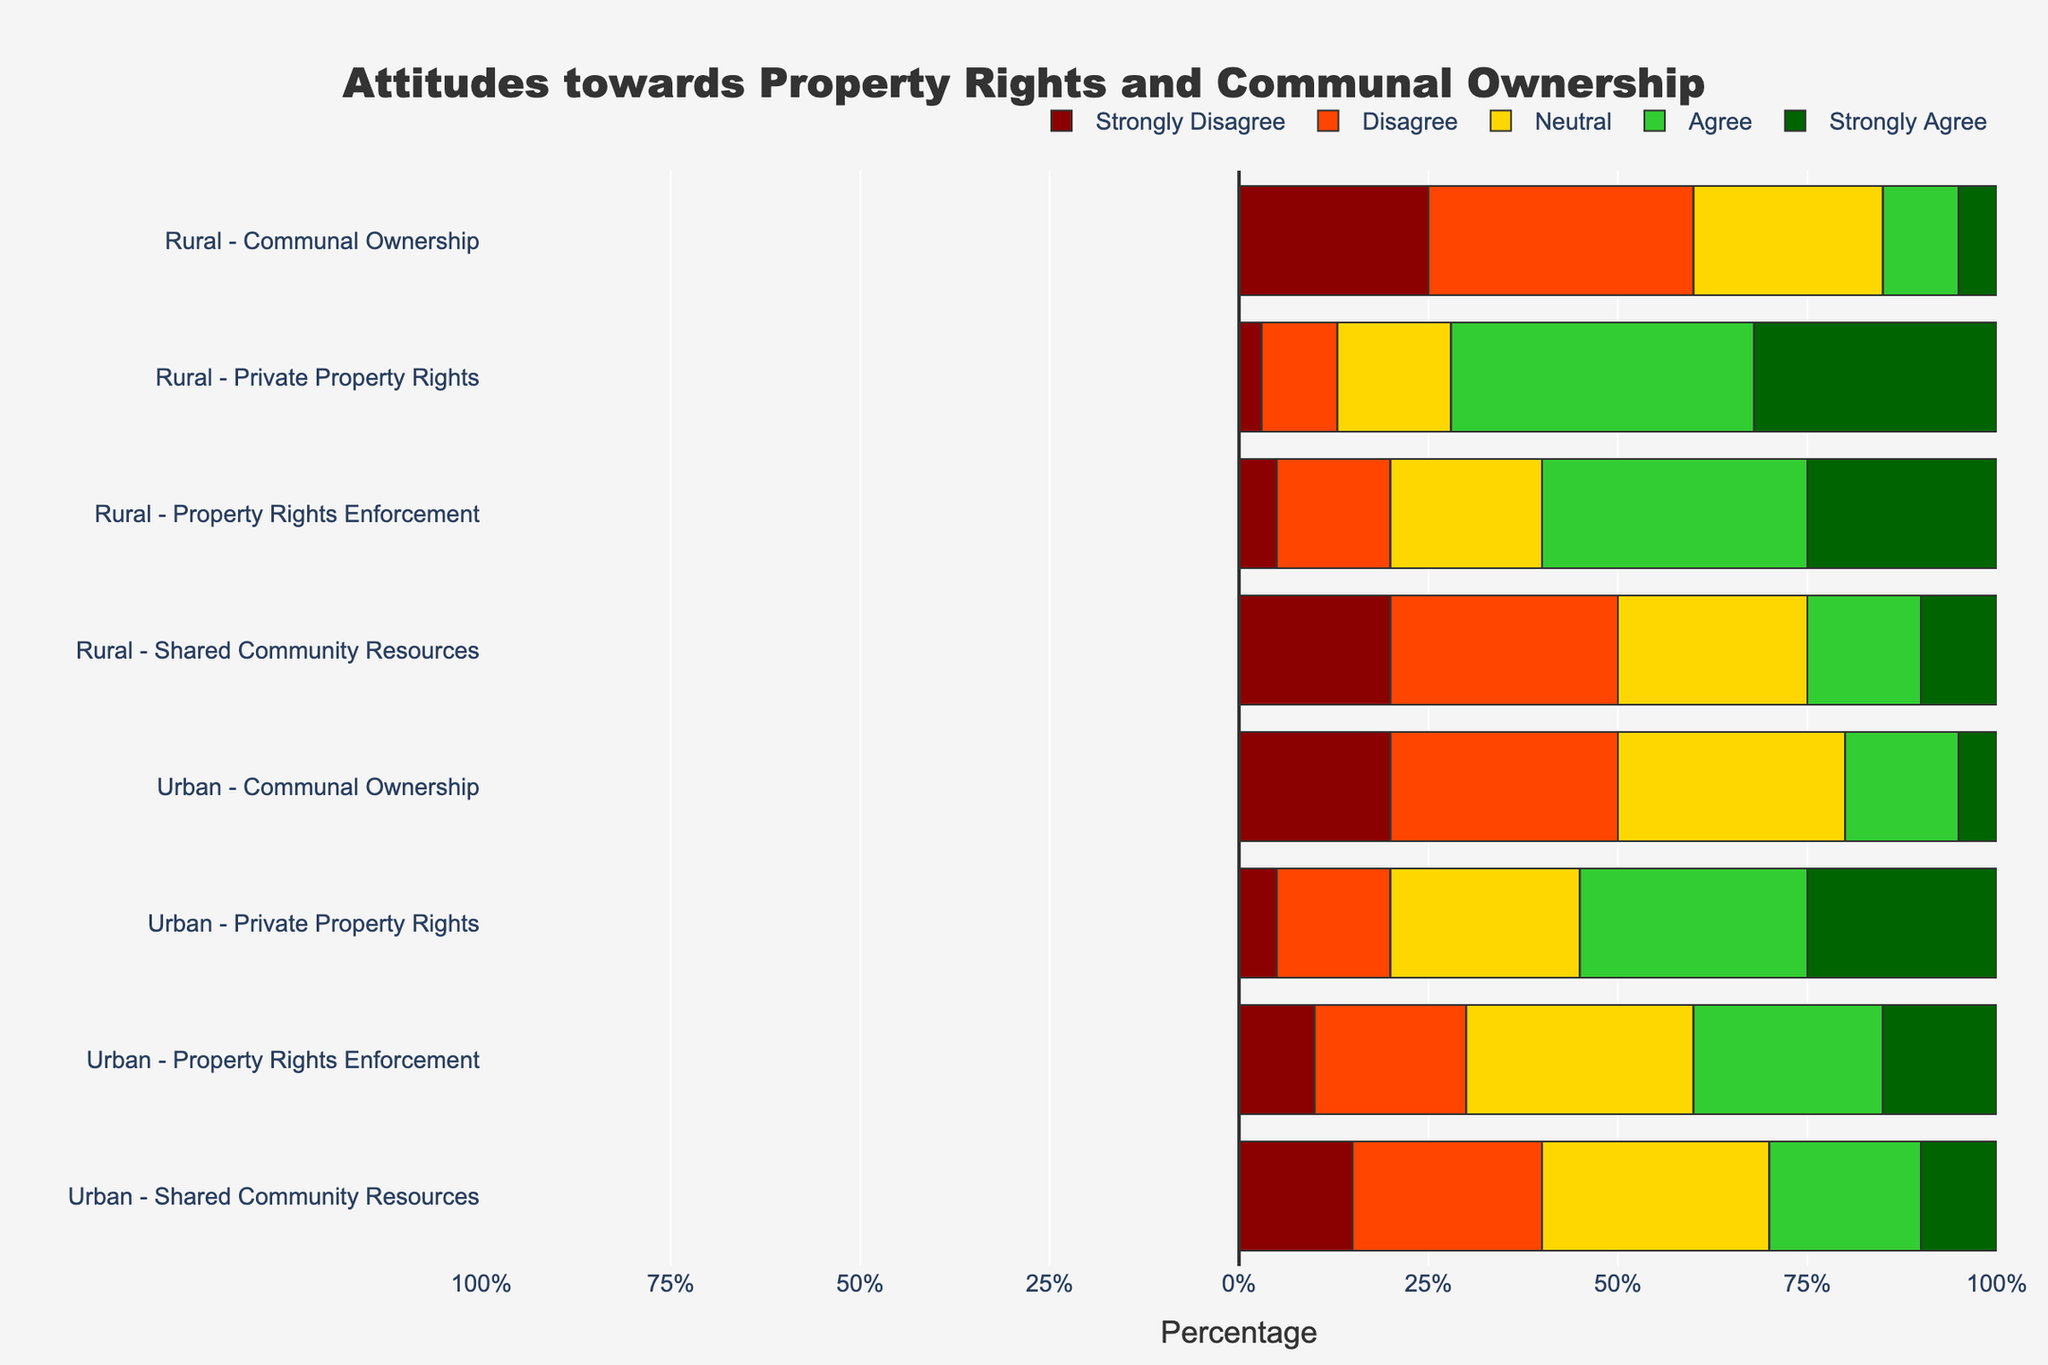What percentage of rural respondents strongly agree with private property rights compared to urban respondents? To find the percentage of rural respondents who strongly agree with private property rights, look at the bar corresponding to the "Strongly Agree" section for rural-private property rights. Do the same for urban respondents. The values are 32% for rural and 25% for urban. So, rural respondents have a higher percentage.
Answer: Rural: 32%, Urban: 25% Which category has the highest percentage of respondents who strongly disagree in the urban population? Look at all the categories for urban and identify which one has the longest bar in the "Strongly Disagree" section. For urban categories, private property rights have 5%, communal ownership has 20%, property rights enforcement has 10%, and shared community resources have 15%. Hence, communal ownership has the highest percentage.
Answer: Communal ownership: 20% What's the difference in the percentage of rural respondents that agree versus disagree with property rights enforcement? Find the percentage of rural respondents that "Agree" (35%) and "Disagree" (15%) with property rights enforcement. Calculate the difference: 35% - 15% = 20%. Hence, the difference is 20%.
Answer: 20% Which category has the most neutral responses across both urban and rural populations? Compare the "Neutral" bars for all categories in both populations. Urban and rural categories have the following neutral responses: private property rights (25% urban, 15% rural), communal ownership (30% urban, 25% rural), property rights enforcement (30% urban, 20% rural), and shared community resources (30% urban, 25% rural). The communal ownership in urban has the highest neutral responses at 30%.
Answer: Communal ownership (Urban): 30% How does the attitude toward shared community resources compare between urban and rural populations? Compare the bars for each response category (Strongly Disagree, Disagree, Neutral, Agree, Strongly Agree) between urban and rural for shared community resources. Urban has 15% strongly disagree, 25% disagree, 30% neutral, 20% agree, and 10% strongly agree. Rural has 20% strongly disagree, 30% disagree, 25% neutral, 15% agree, and 10% strongly agree. Urban respondents are more neutral and agree more, while rural respondents are more inclined to disagree.
Answer: Urban: more neutral and agree, Rural: more disagree Is there more consensus on private property rights or communal ownership among rural respondents? Consensus can be inferred by looking at the concentration of responses towards "Strongly Agree" and "Agree" or "Strongly Disagree" and "Disagree." For rural-private property rights, 72% fall into agree or strongly agree (40% + 32%), and for rural-communal ownership, 60% fall into strongly disagree or disagree (25% + 35%). Therefore, rural respondents have more consensus on private property rights.
Answer: Private property rights What is the combined percentage of urban respondents who either agree or strongly agree with communal ownership? To find the combined percentage, add the "Agree" and "Strongly Agree" for urban communal ownership: 15% (agree) + 5% (strongly agree) = 20%.
Answer: 20% Compare the level of strong disagreement with shared community resources between urban and rural populations. Look at the "Strongly Disagree" bars for shared community resources in both urban and rural populations. Urban has 15%, and rural has 20%. Therefore, rural populations express a higher level of strong disagreement.
Answer: Rural: 20%, Urban: 15% How does the attitude towards communal ownership among urban respondents compare to rural respondents in terms of strong agreement? Observe the "Strongly Agree" categories for communal ownership among both populations. Urban has 5%, and rural also has 5%. Hence, they are equal in terms of strong agreement.
Answer: Equal What's the ratio of urban to rural respondents who strongly disagree with property rights enforcement? Examine the "Strongly Disagree" bars for property rights enforcement among urban and rural populations. Urban has 10%, and rural has 5%. Thus, the ratio is 10% to 5%, which simplifies to 2:1.
Answer: 2:1 